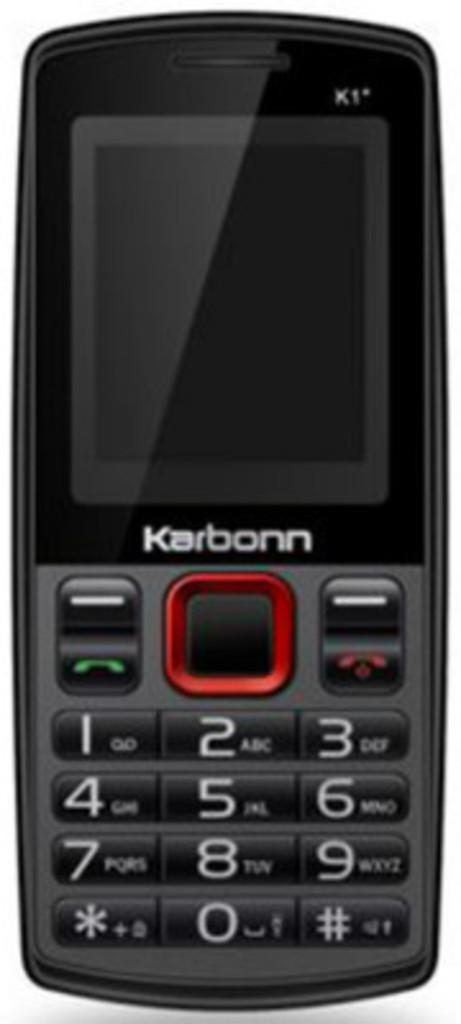<image>
Give a short and clear explanation of the subsequent image. a black trac cell phone by karbonn with built in keyboard 